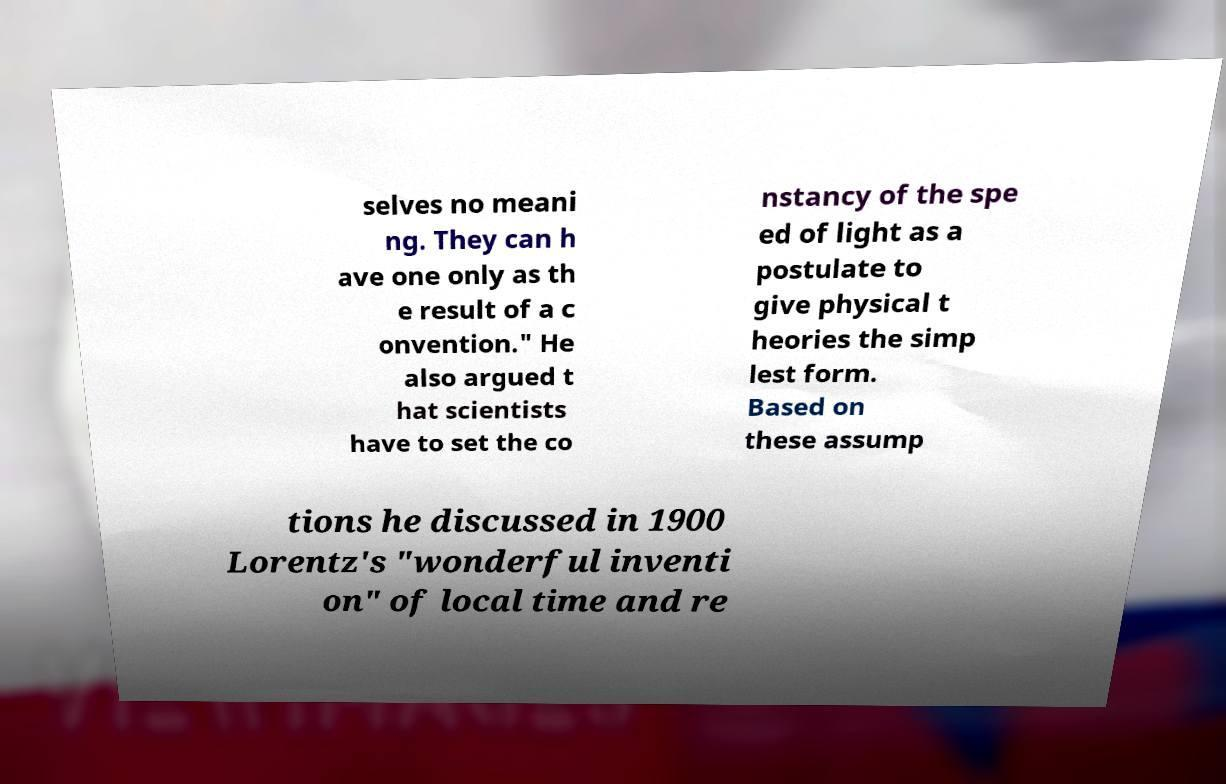Could you extract and type out the text from this image? selves no meani ng. They can h ave one only as th e result of a c onvention." He also argued t hat scientists have to set the co nstancy of the spe ed of light as a postulate to give physical t heories the simp lest form. Based on these assump tions he discussed in 1900 Lorentz's "wonderful inventi on" of local time and re 